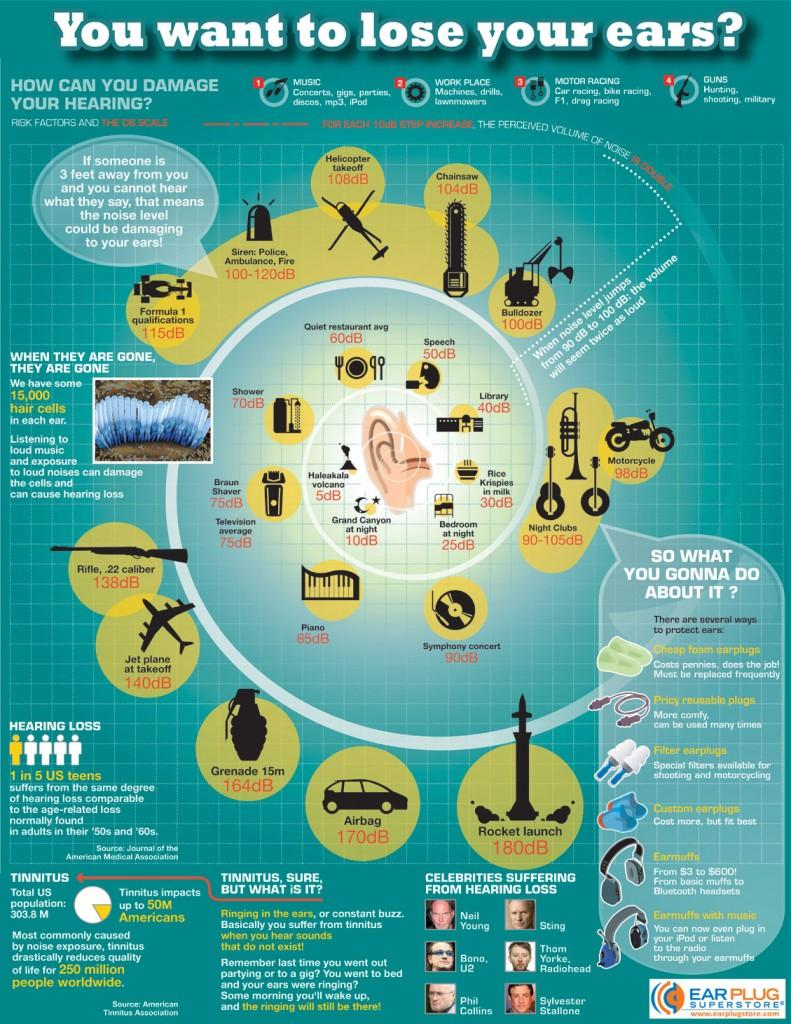Specify some key components in this picture. The sound level at a library is typically around 40 decibels. Phil Collins and Sylvester Stallone both suffer from hearing loss. The cheapest way to protect one's ears from loud noises is by using foam earplugs, which are a cost-effective and efficient solution. The average sound level at the Grand Canyon at night is approximately 10 decibels lower than the average sound level during the day. If the hair cells in the cochlea are damaged by loud noises and loud music, it can result in hearing loss. 